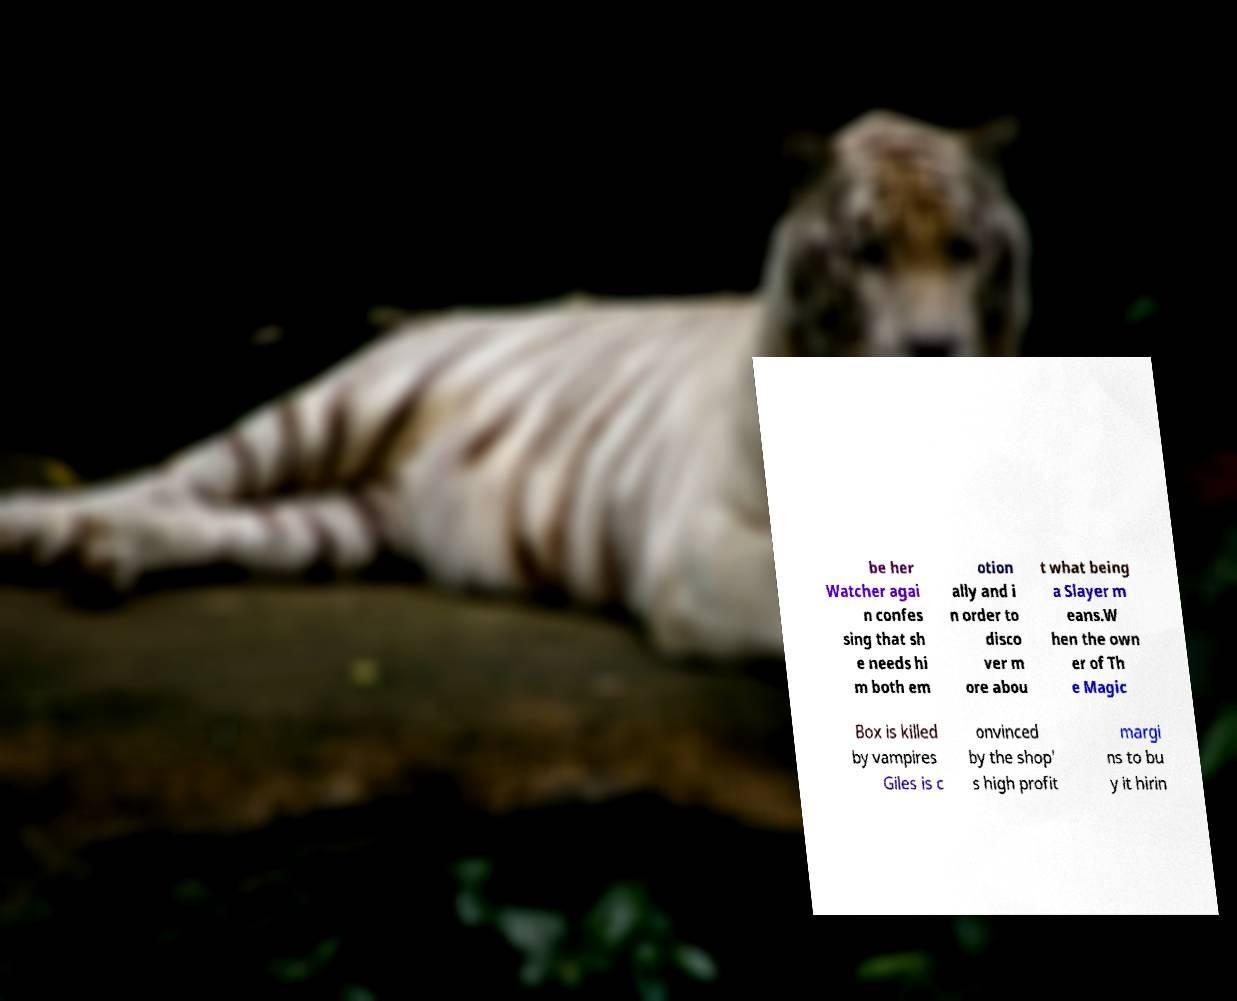There's text embedded in this image that I need extracted. Can you transcribe it verbatim? be her Watcher agai n confes sing that sh e needs hi m both em otion ally and i n order to disco ver m ore abou t what being a Slayer m eans.W hen the own er of Th e Magic Box is killed by vampires Giles is c onvinced by the shop' s high profit margi ns to bu y it hirin 